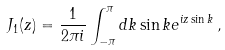<formula> <loc_0><loc_0><loc_500><loc_500>J _ { 1 } ( z ) = \frac { 1 } { 2 \pi i } \int _ { - \pi } ^ { \pi } d k \sin k e ^ { i z \sin k } \, ,</formula> 